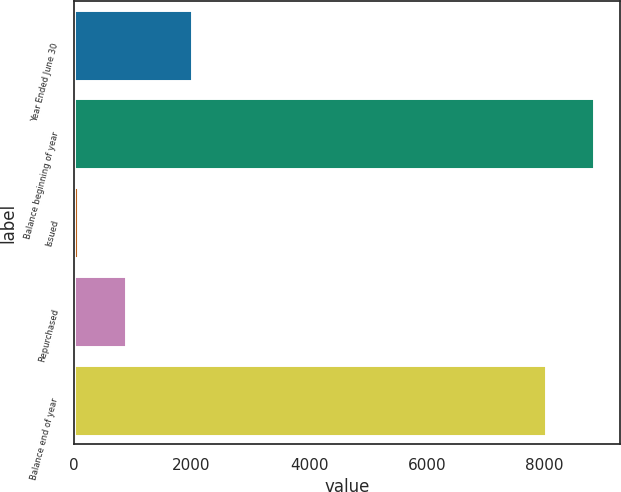Convert chart. <chart><loc_0><loc_0><loc_500><loc_500><bar_chart><fcel>Year Ended June 30<fcel>Balance beginning of year<fcel>Issued<fcel>Repurchased<fcel>Balance end of year<nl><fcel>2015<fcel>8842.6<fcel>83<fcel>898.6<fcel>8027<nl></chart> 